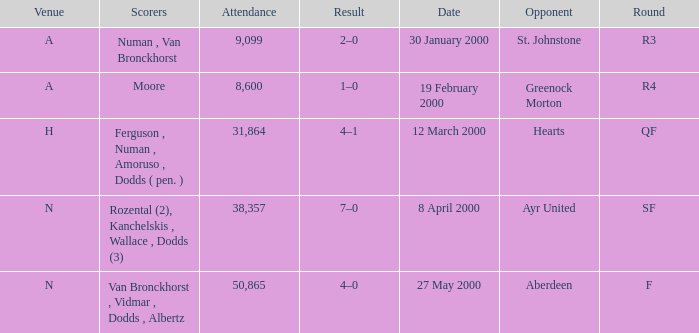Who was on 12 March 2000? Ferguson , Numan , Amoruso , Dodds ( pen. ). 